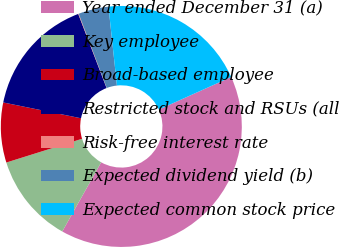Convert chart. <chart><loc_0><loc_0><loc_500><loc_500><pie_chart><fcel>Year ended December 31 (a)<fcel>Key employee<fcel>Broad-based employee<fcel>Restricted stock and RSUs (all<fcel>Risk-free interest rate<fcel>Expected dividend yield (b)<fcel>Expected common stock price<nl><fcel>39.88%<fcel>12.01%<fcel>8.03%<fcel>15.99%<fcel>0.07%<fcel>4.05%<fcel>19.97%<nl></chart> 